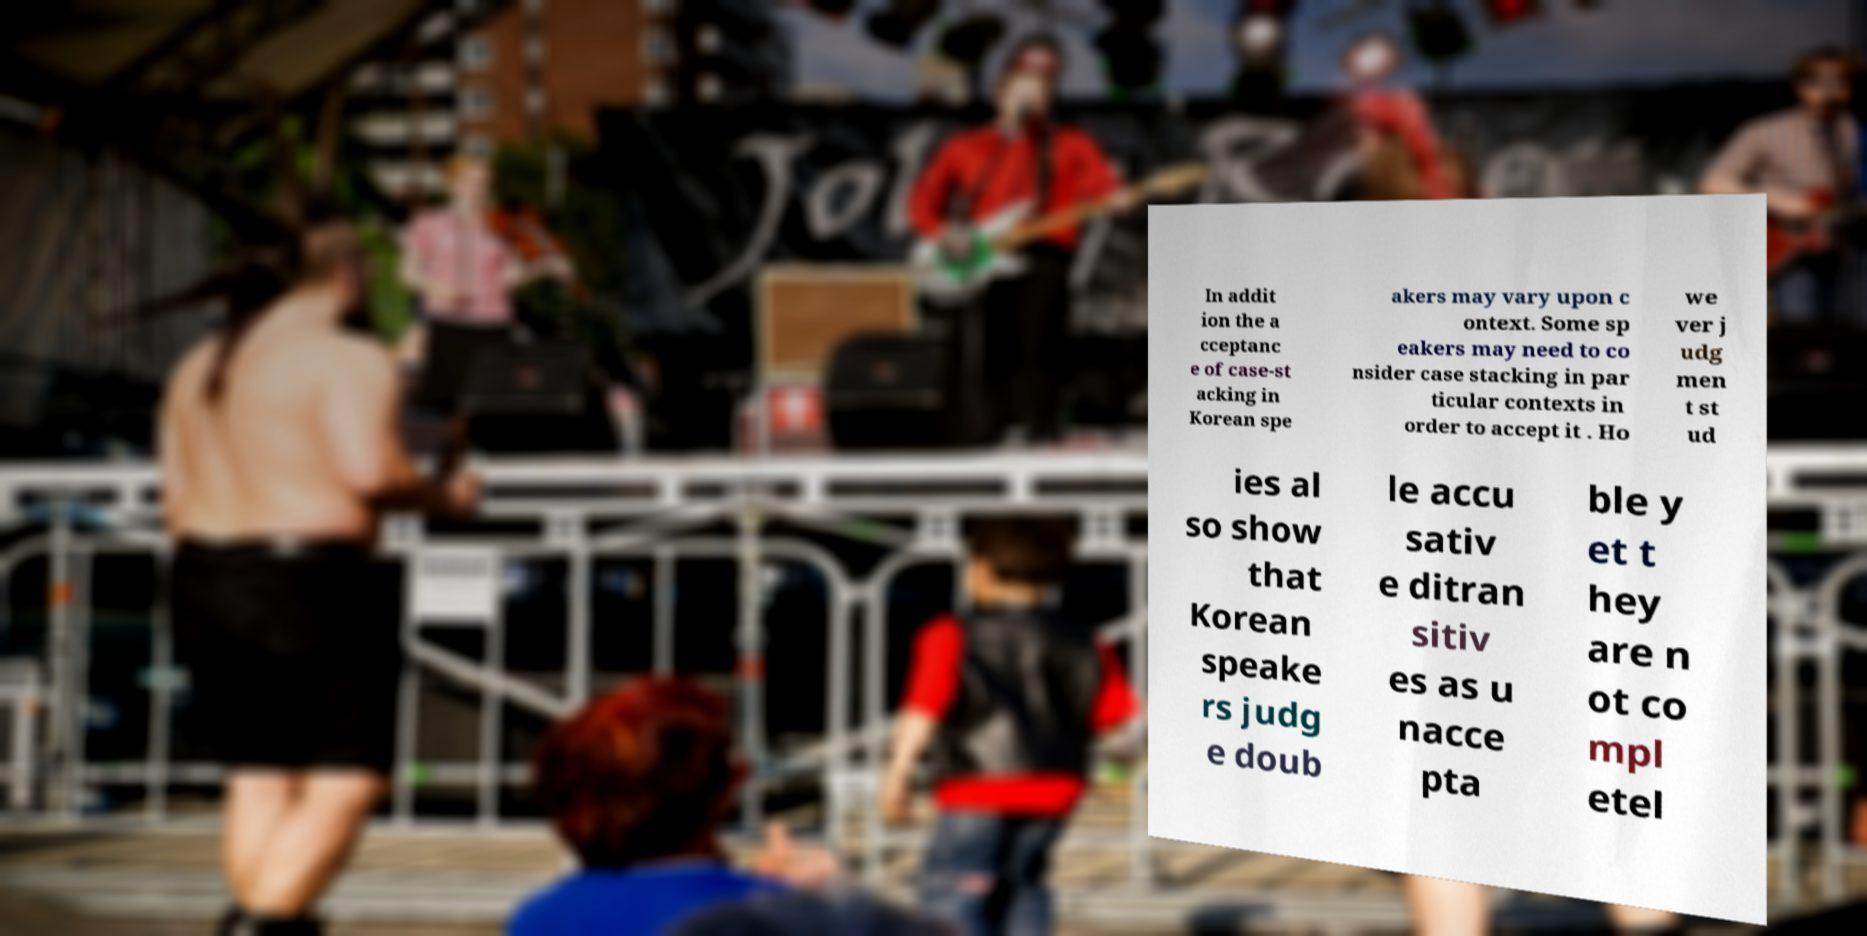Could you assist in decoding the text presented in this image and type it out clearly? In addit ion the a cceptanc e of case-st acking in Korean spe akers may vary upon c ontext. Some sp eakers may need to co nsider case stacking in par ticular contexts in order to accept it . Ho we ver j udg men t st ud ies al so show that Korean speake rs judg e doub le accu sativ e ditran sitiv es as u nacce pta ble y et t hey are n ot co mpl etel 